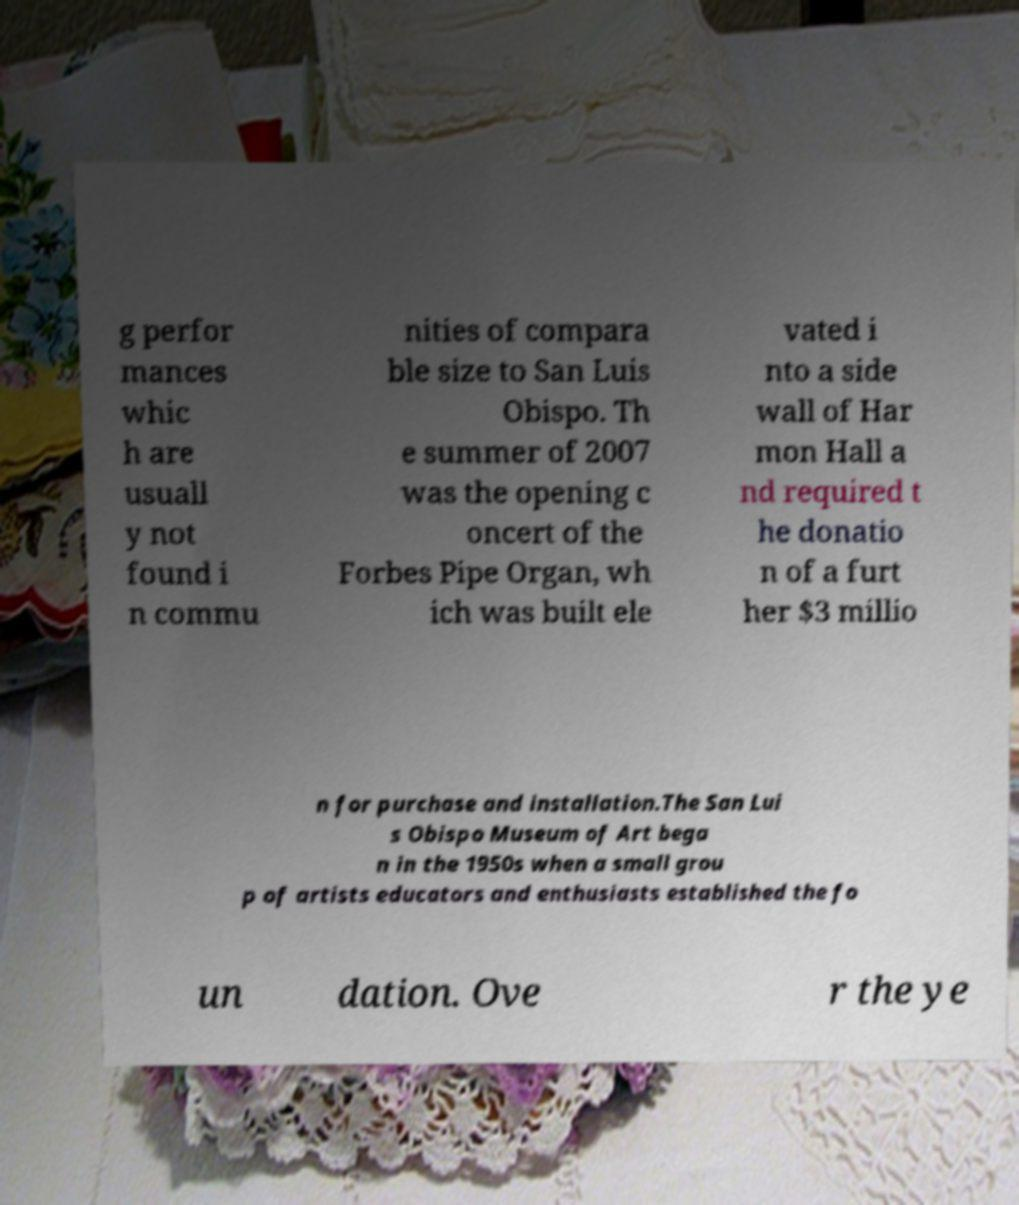Could you extract and type out the text from this image? g perfor mances whic h are usuall y not found i n commu nities of compara ble size to San Luis Obispo. Th e summer of 2007 was the opening c oncert of the Forbes Pipe Organ, wh ich was built ele vated i nto a side wall of Har mon Hall a nd required t he donatio n of a furt her $3 millio n for purchase and installation.The San Lui s Obispo Museum of Art bega n in the 1950s when a small grou p of artists educators and enthusiasts established the fo un dation. Ove r the ye 